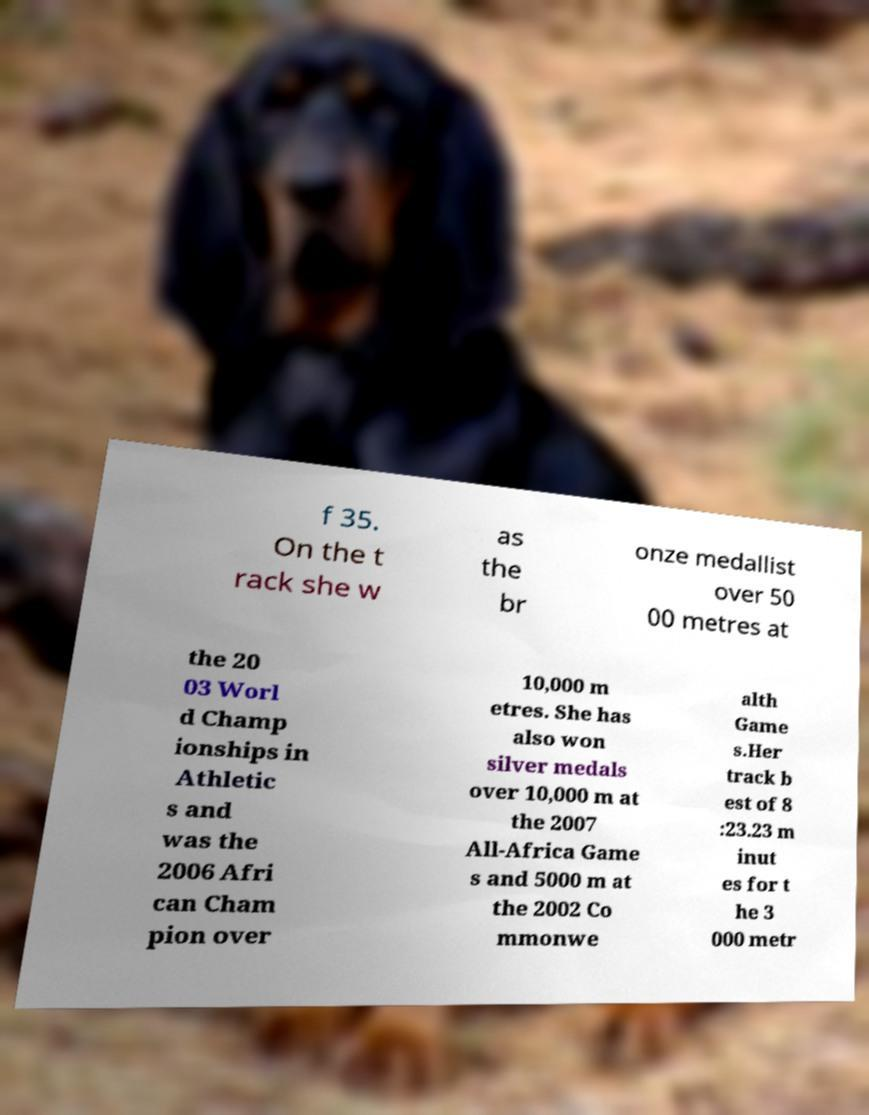Can you accurately transcribe the text from the provided image for me? f 35. On the t rack she w as the br onze medallist over 50 00 metres at the 20 03 Worl d Champ ionships in Athletic s and was the 2006 Afri can Cham pion over 10,000 m etres. She has also won silver medals over 10,000 m at the 2007 All-Africa Game s and 5000 m at the 2002 Co mmonwe alth Game s.Her track b est of 8 :23.23 m inut es for t he 3 000 metr 